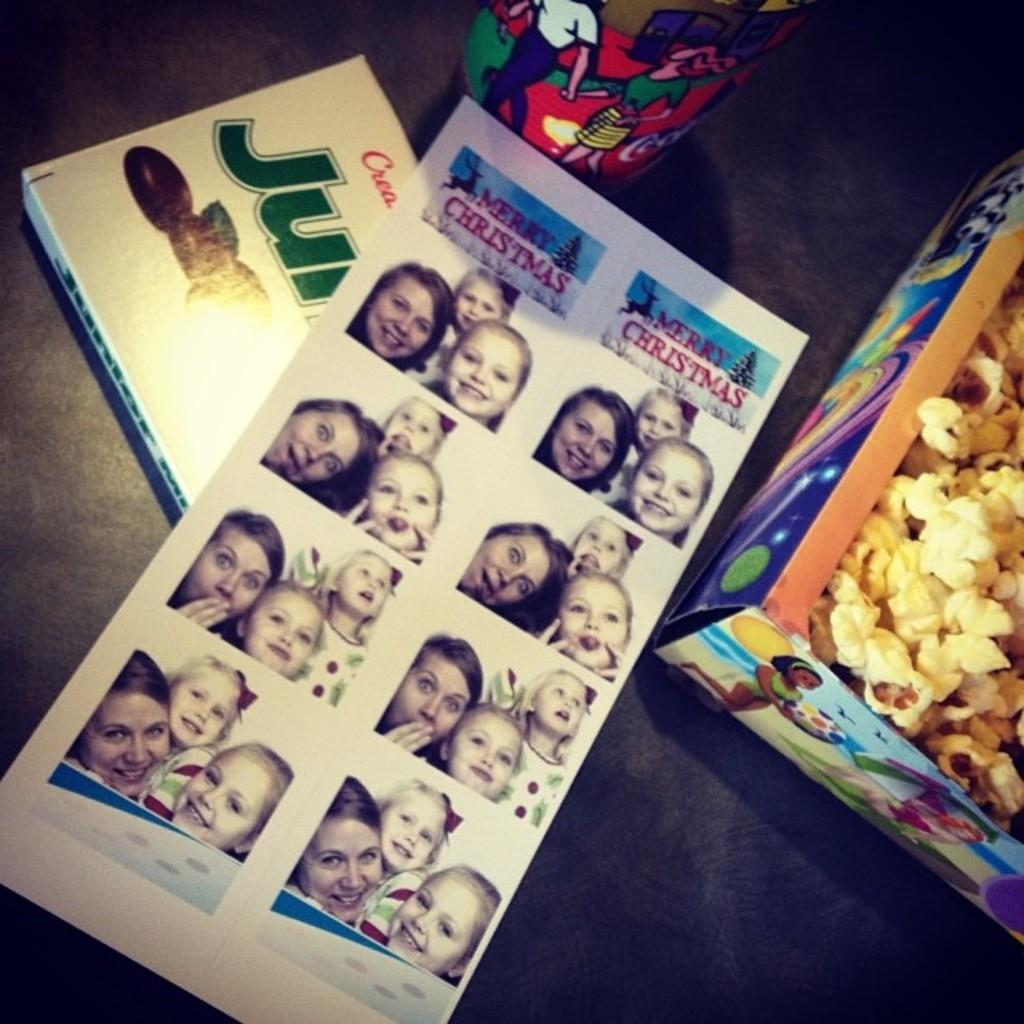What type of items can be seen in the image? There are books, a box with popcorn, and a cup in the image. What might be used for holding food or drink in the image? The cup in the image can be used for holding food or drink. What is the color of the surface on which the objects are placed? The objects are placed on a black color surface. How many bees are buzzing around the books in the image? There are no bees present in the image; it only features books, a box with popcorn, and a cup on a black surface. 